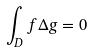<formula> <loc_0><loc_0><loc_500><loc_500>\int _ { D } f \Delta g = 0</formula> 